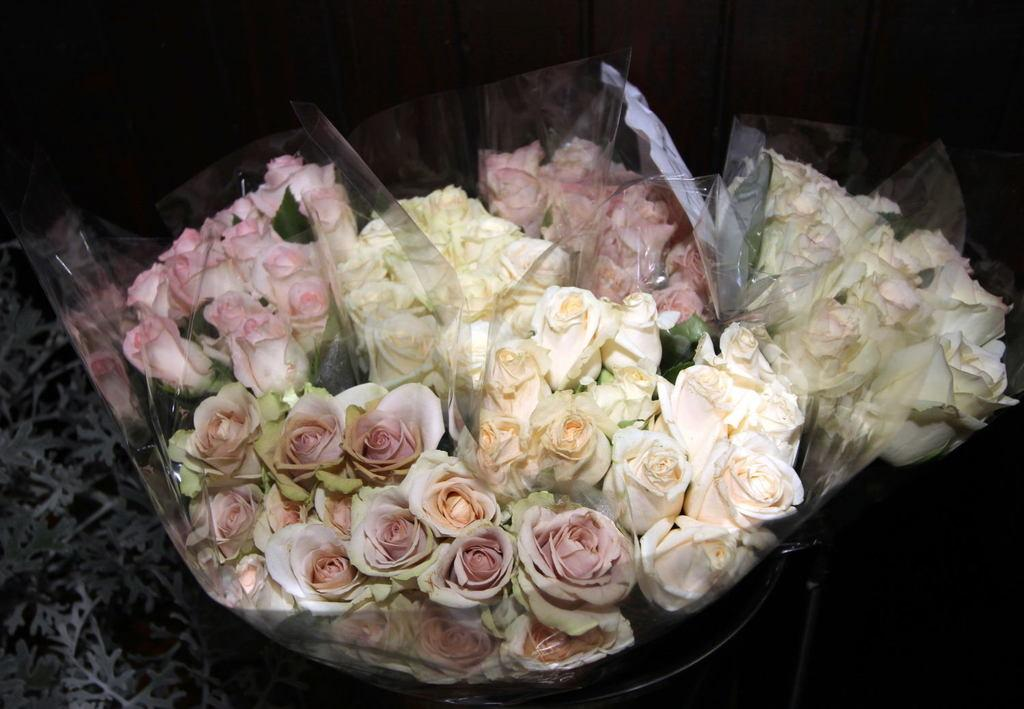What type of flowers can be seen in the image? There are flowers in the image, including pink roses and white roses. How are the flowers arranged or presented in the image? The flowers are wrapped in a plastic sheet. What type of hat is worn by the harmony in the image? There is no harmony or hat present in the image; it features flowers wrapped in a plastic sheet. 